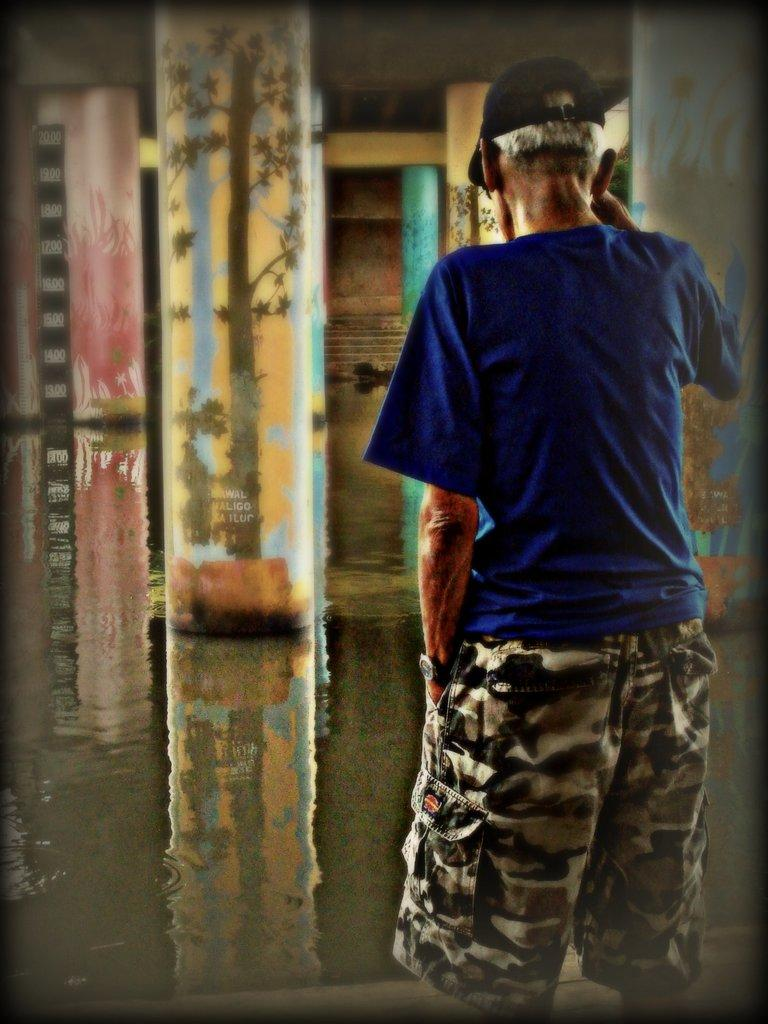What is the person in the image wearing on their head? The person is wearing a cap in the image. Where is the person located in the image? The person is standing on the ground in the image. What can be seen in the background of the image? There is a board with numbers and poles in the background of the image. What type of fuel is being used by the person in the image? There is no indication of fuel being used in the image; the person is simply standing on the ground. 